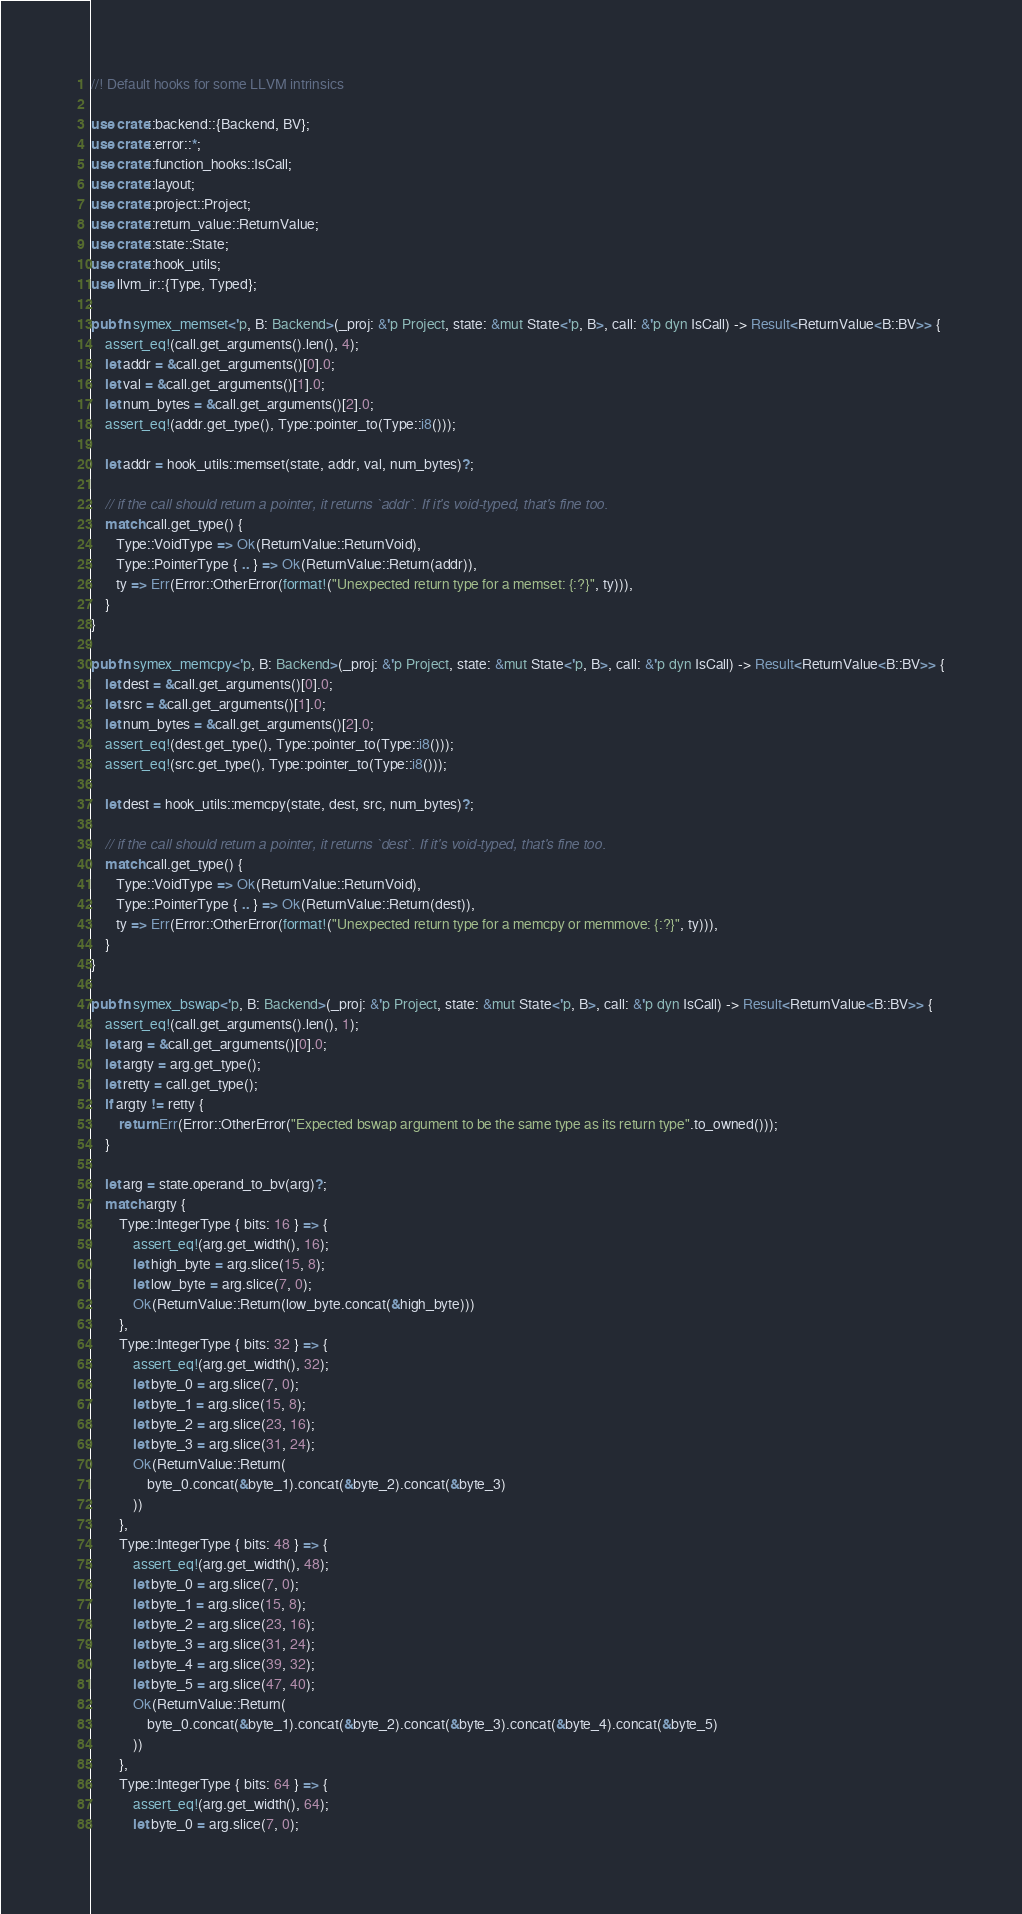Convert code to text. <code><loc_0><loc_0><loc_500><loc_500><_Rust_>//! Default hooks for some LLVM intrinsics

use crate::backend::{Backend, BV};
use crate::error::*;
use crate::function_hooks::IsCall;
use crate::layout;
use crate::project::Project;
use crate::return_value::ReturnValue;
use crate::state::State;
use crate::hook_utils;
use llvm_ir::{Type, Typed};

pub fn symex_memset<'p, B: Backend>(_proj: &'p Project, state: &mut State<'p, B>, call: &'p dyn IsCall) -> Result<ReturnValue<B::BV>> {
    assert_eq!(call.get_arguments().len(), 4);
    let addr = &call.get_arguments()[0].0;
    let val = &call.get_arguments()[1].0;
    let num_bytes = &call.get_arguments()[2].0;
    assert_eq!(addr.get_type(), Type::pointer_to(Type::i8()));

    let addr = hook_utils::memset(state, addr, val, num_bytes)?;

    // if the call should return a pointer, it returns `addr`. If it's void-typed, that's fine too.
    match call.get_type() {
       Type::VoidType => Ok(ReturnValue::ReturnVoid),
       Type::PointerType { .. } => Ok(ReturnValue::Return(addr)),
       ty => Err(Error::OtherError(format!("Unexpected return type for a memset: {:?}", ty))),
    }
}

pub fn symex_memcpy<'p, B: Backend>(_proj: &'p Project, state: &mut State<'p, B>, call: &'p dyn IsCall) -> Result<ReturnValue<B::BV>> {
    let dest = &call.get_arguments()[0].0;
    let src = &call.get_arguments()[1].0;
    let num_bytes = &call.get_arguments()[2].0;
    assert_eq!(dest.get_type(), Type::pointer_to(Type::i8()));
    assert_eq!(src.get_type(), Type::pointer_to(Type::i8()));

    let dest = hook_utils::memcpy(state, dest, src, num_bytes)?;

    // if the call should return a pointer, it returns `dest`. If it's void-typed, that's fine too.
    match call.get_type() {
       Type::VoidType => Ok(ReturnValue::ReturnVoid),
       Type::PointerType { .. } => Ok(ReturnValue::Return(dest)),
       ty => Err(Error::OtherError(format!("Unexpected return type for a memcpy or memmove: {:?}", ty))),
    }
}

pub fn symex_bswap<'p, B: Backend>(_proj: &'p Project, state: &mut State<'p, B>, call: &'p dyn IsCall) -> Result<ReturnValue<B::BV>> {
    assert_eq!(call.get_arguments().len(), 1);
    let arg = &call.get_arguments()[0].0;
    let argty = arg.get_type();
    let retty = call.get_type();
    if argty != retty {
        return Err(Error::OtherError("Expected bswap argument to be the same type as its return type".to_owned()));
    }

    let arg = state.operand_to_bv(arg)?;
    match argty {
        Type::IntegerType { bits: 16 } => {
            assert_eq!(arg.get_width(), 16);
            let high_byte = arg.slice(15, 8);
            let low_byte = arg.slice(7, 0);
            Ok(ReturnValue::Return(low_byte.concat(&high_byte)))
        },
        Type::IntegerType { bits: 32 } => {
            assert_eq!(arg.get_width(), 32);
            let byte_0 = arg.slice(7, 0);
            let byte_1 = arg.slice(15, 8);
            let byte_2 = arg.slice(23, 16);
            let byte_3 = arg.slice(31, 24);
            Ok(ReturnValue::Return(
                byte_0.concat(&byte_1).concat(&byte_2).concat(&byte_3)
            ))
        },
        Type::IntegerType { bits: 48 } => {
            assert_eq!(arg.get_width(), 48);
            let byte_0 = arg.slice(7, 0);
            let byte_1 = arg.slice(15, 8);
            let byte_2 = arg.slice(23, 16);
            let byte_3 = arg.slice(31, 24);
            let byte_4 = arg.slice(39, 32);
            let byte_5 = arg.slice(47, 40);
            Ok(ReturnValue::Return(
                byte_0.concat(&byte_1).concat(&byte_2).concat(&byte_3).concat(&byte_4).concat(&byte_5)
            ))
        },
        Type::IntegerType { bits: 64 } => {
            assert_eq!(arg.get_width(), 64);
            let byte_0 = arg.slice(7, 0);</code> 